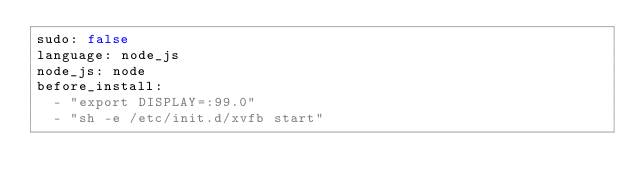<code> <loc_0><loc_0><loc_500><loc_500><_YAML_>sudo: false
language: node_js
node_js: node
before_install:
  - "export DISPLAY=:99.0"
  - "sh -e /etc/init.d/xvfb start"</code> 